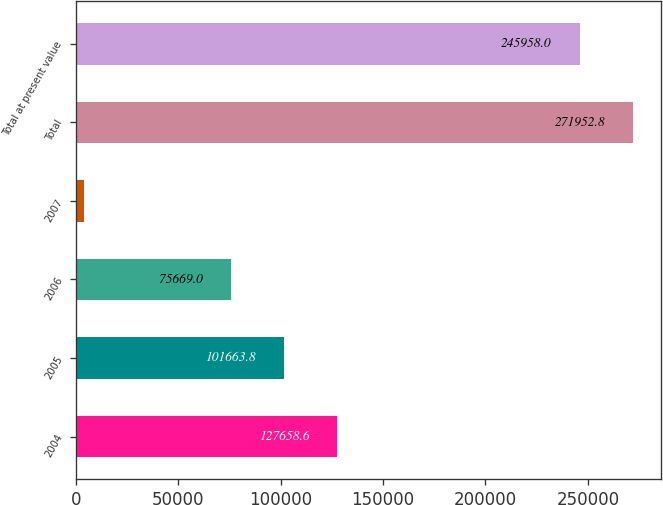Convert chart. <chart><loc_0><loc_0><loc_500><loc_500><bar_chart><fcel>2004<fcel>2005<fcel>2006<fcel>2007<fcel>Total<fcel>Total at present value<nl><fcel>127659<fcel>101664<fcel>75669<fcel>3939<fcel>271953<fcel>245958<nl></chart> 